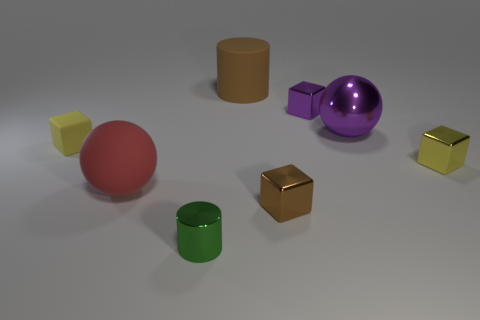There is a shiny block that is behind the tiny yellow object that is to the left of the brown rubber thing; is there a small metallic block behind it?
Your answer should be compact. No. There is a green thing that is made of the same material as the tiny brown thing; what shape is it?
Your answer should be very brief. Cylinder. Is the number of large rubber objects greater than the number of green blocks?
Give a very brief answer. Yes. Does the small purple object have the same shape as the brown object in front of the tiny matte cube?
Make the answer very short. Yes. What is the purple ball made of?
Offer a very short reply. Metal. There is a large object in front of the big thing that is to the right of the big cylinder that is behind the tiny purple thing; what color is it?
Keep it short and to the point. Red. What material is the purple thing that is the same shape as the brown metallic object?
Offer a terse response. Metal. How many green things are the same size as the purple cube?
Your response must be concise. 1. How many small brown metal blocks are there?
Offer a very short reply. 1. Do the small green cylinder and the big brown object that is behind the big metal thing have the same material?
Provide a succinct answer. No. 